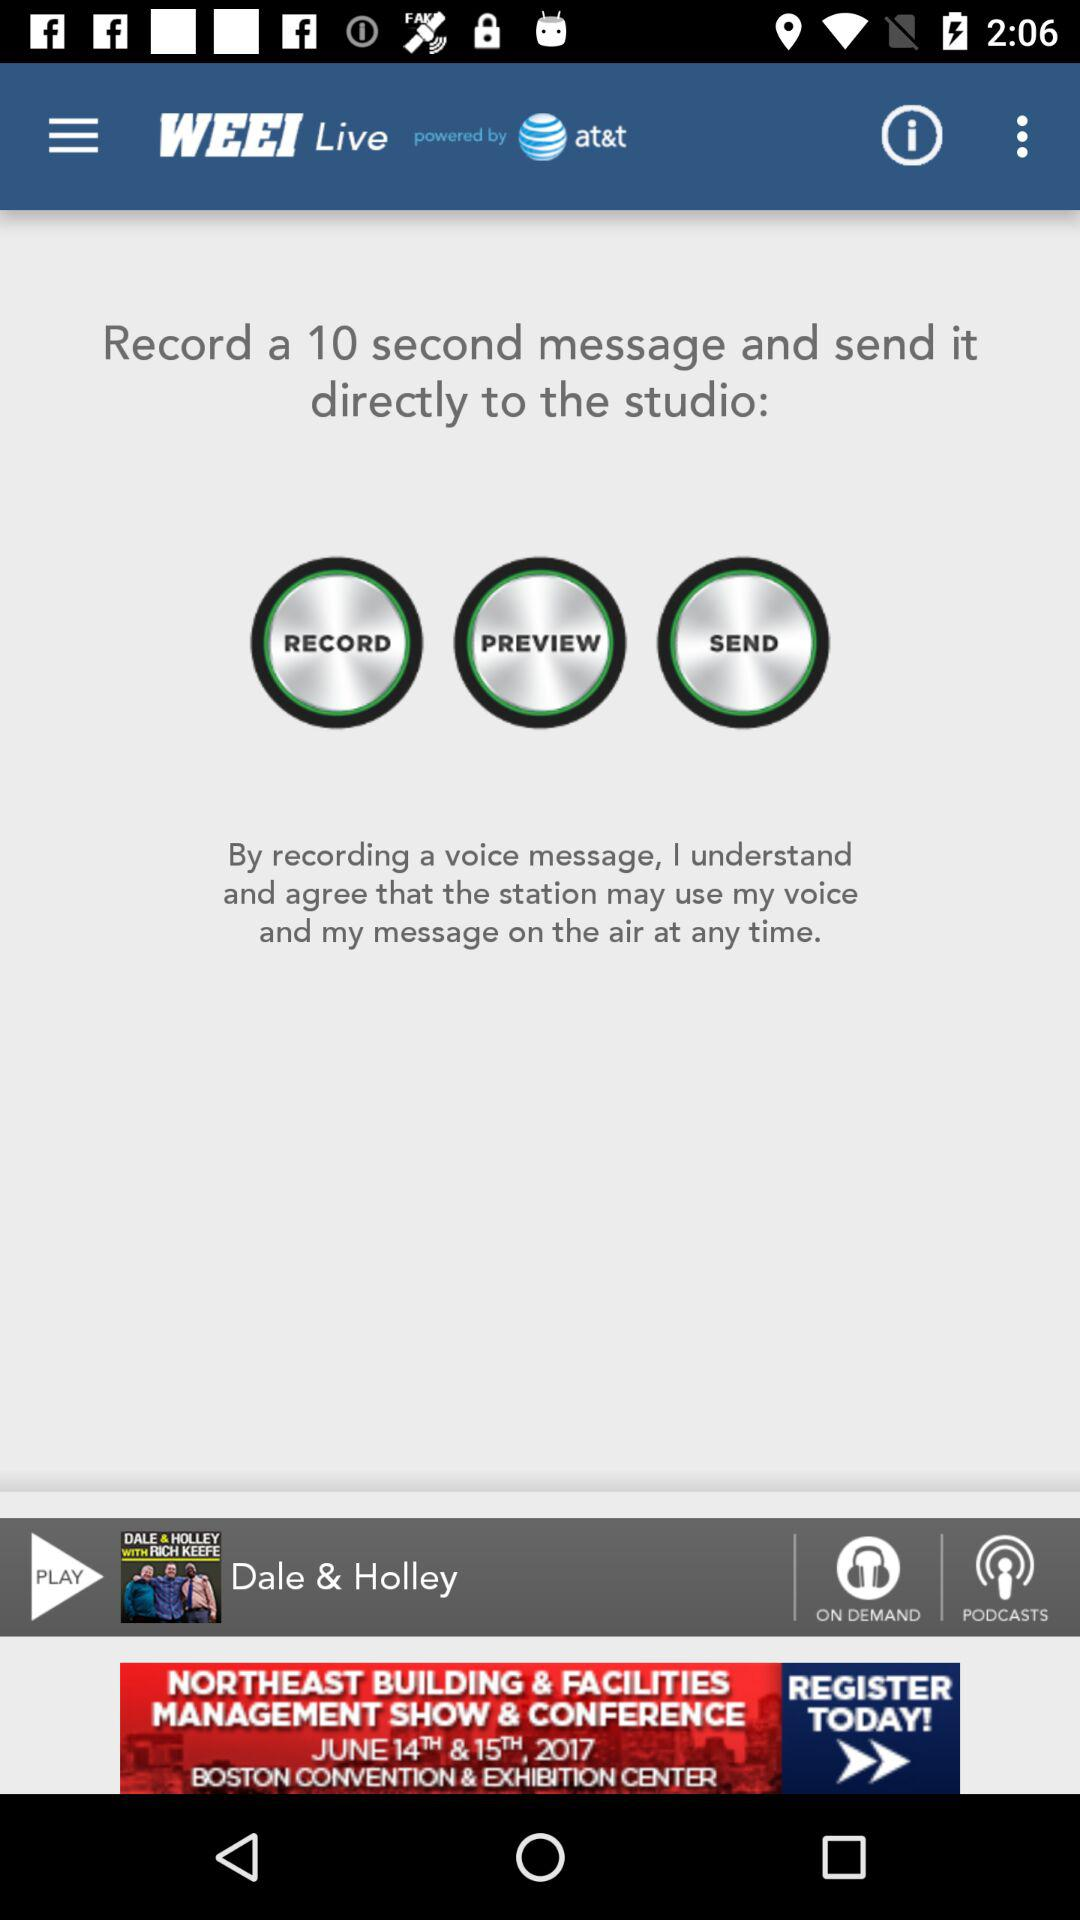What is the application name? The application name is "WEEI Live". 